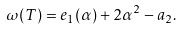Convert formula to latex. <formula><loc_0><loc_0><loc_500><loc_500>\omega ( T ) = e _ { 1 } ( \alpha ) + 2 \alpha ^ { 2 } - a _ { 2 } .</formula> 